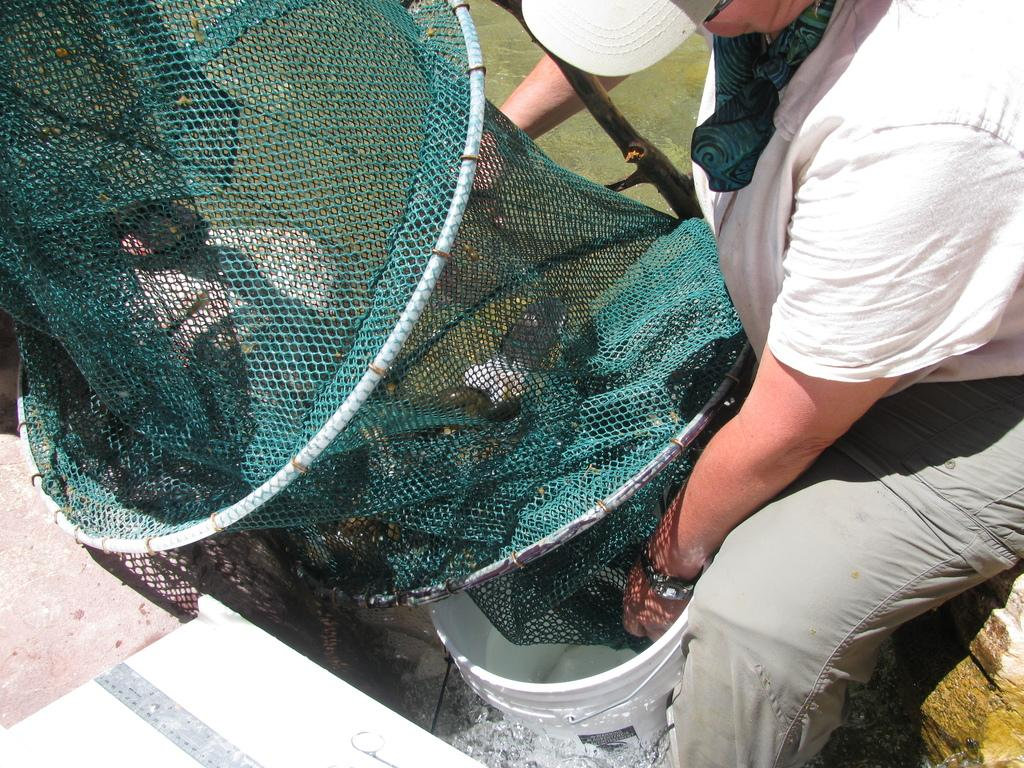What is the person in the image holding? The person is holding a net. What might the person be doing with the net? The presence of a bucket under the net suggests that the person might be catching something with the net. What type of robin can be seen approving the person's actions in the image? There is no robin present in the image, and therefore no such approval can be observed. How many beads can be seen on the person's necklace in the image? There is no mention of a necklace or beads in the image, so it cannot be determined from the picture. 